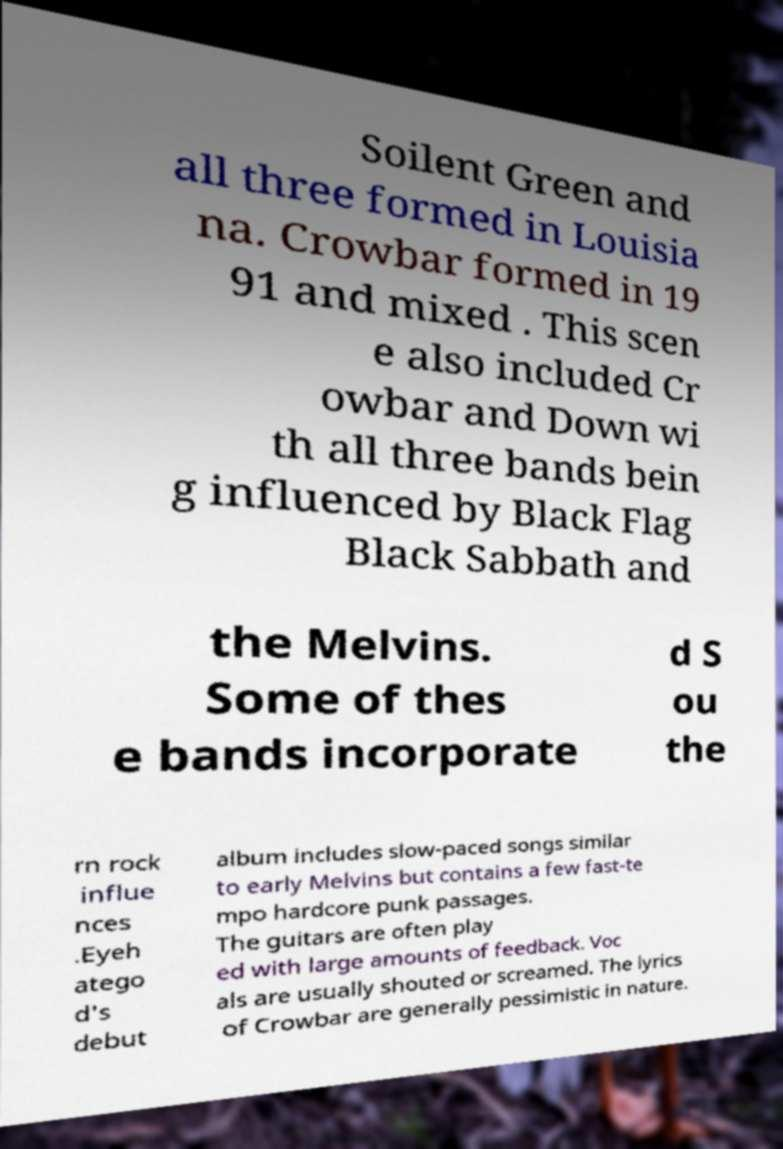What messages or text are displayed in this image? I need them in a readable, typed format. Soilent Green and all three formed in Louisia na. Crowbar formed in 19 91 and mixed . This scen e also included Cr owbar and Down wi th all three bands bein g influenced by Black Flag Black Sabbath and the Melvins. Some of thes e bands incorporate d S ou the rn rock influe nces .Eyeh atego d's debut album includes slow-paced songs similar to early Melvins but contains a few fast-te mpo hardcore punk passages. The guitars are often play ed with large amounts of feedback. Voc als are usually shouted or screamed. The lyrics of Crowbar are generally pessimistic in nature. 